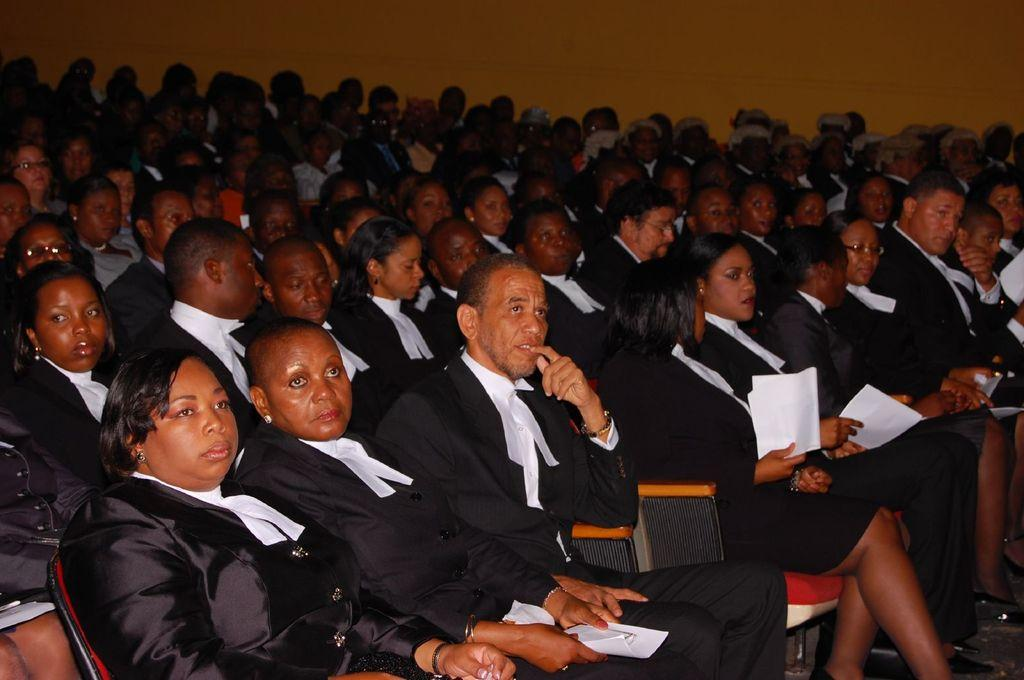Who is present in the image? There are people in the image. What are the people wearing? The people are wearing uniforms. What are the people doing in the image? The people are sitting on chairs. What are some of the people holding in their hands? Some of the people are holding papers in their hands. What can be seen in the background of the image? There is a wall in the background of the image. What type of crayon is being used to draw on the wall in the image? There is no crayon or drawing on the wall in the image. What substance is causing the people to experience shock in the image? There is no indication of shock or any substance causing it in the image. 